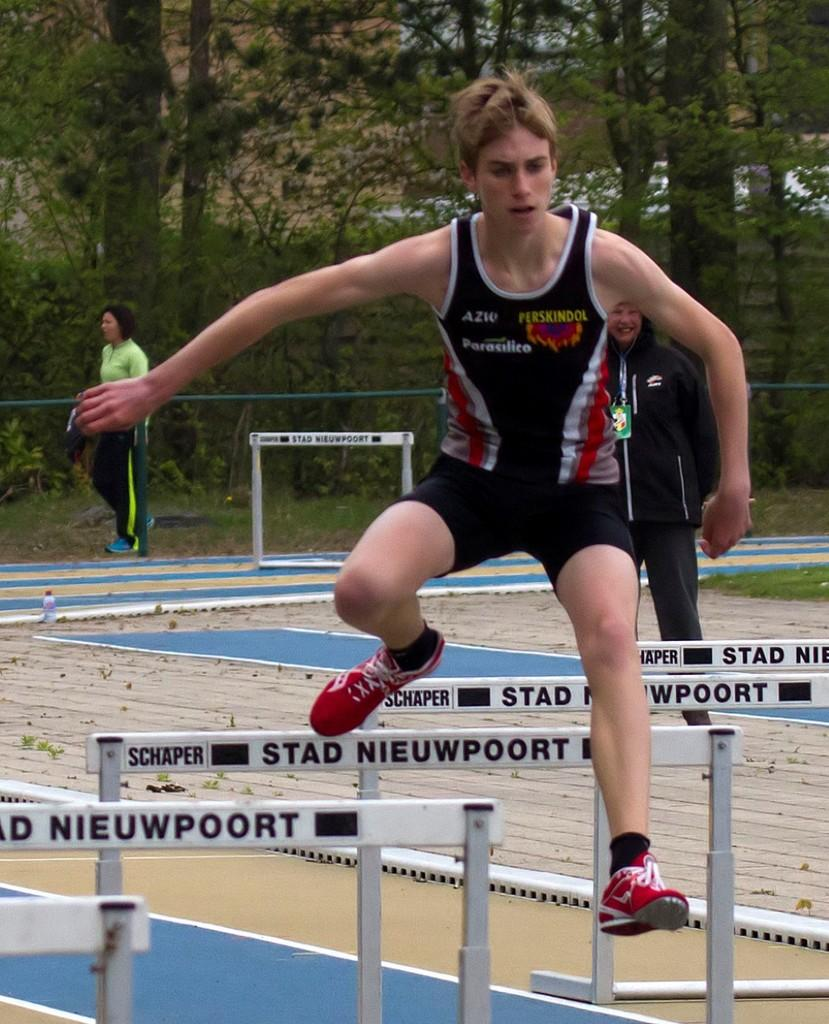<image>
Present a compact description of the photo's key features. A young man jumping over hurdles with the words Stad Nieuwpoort on them. 